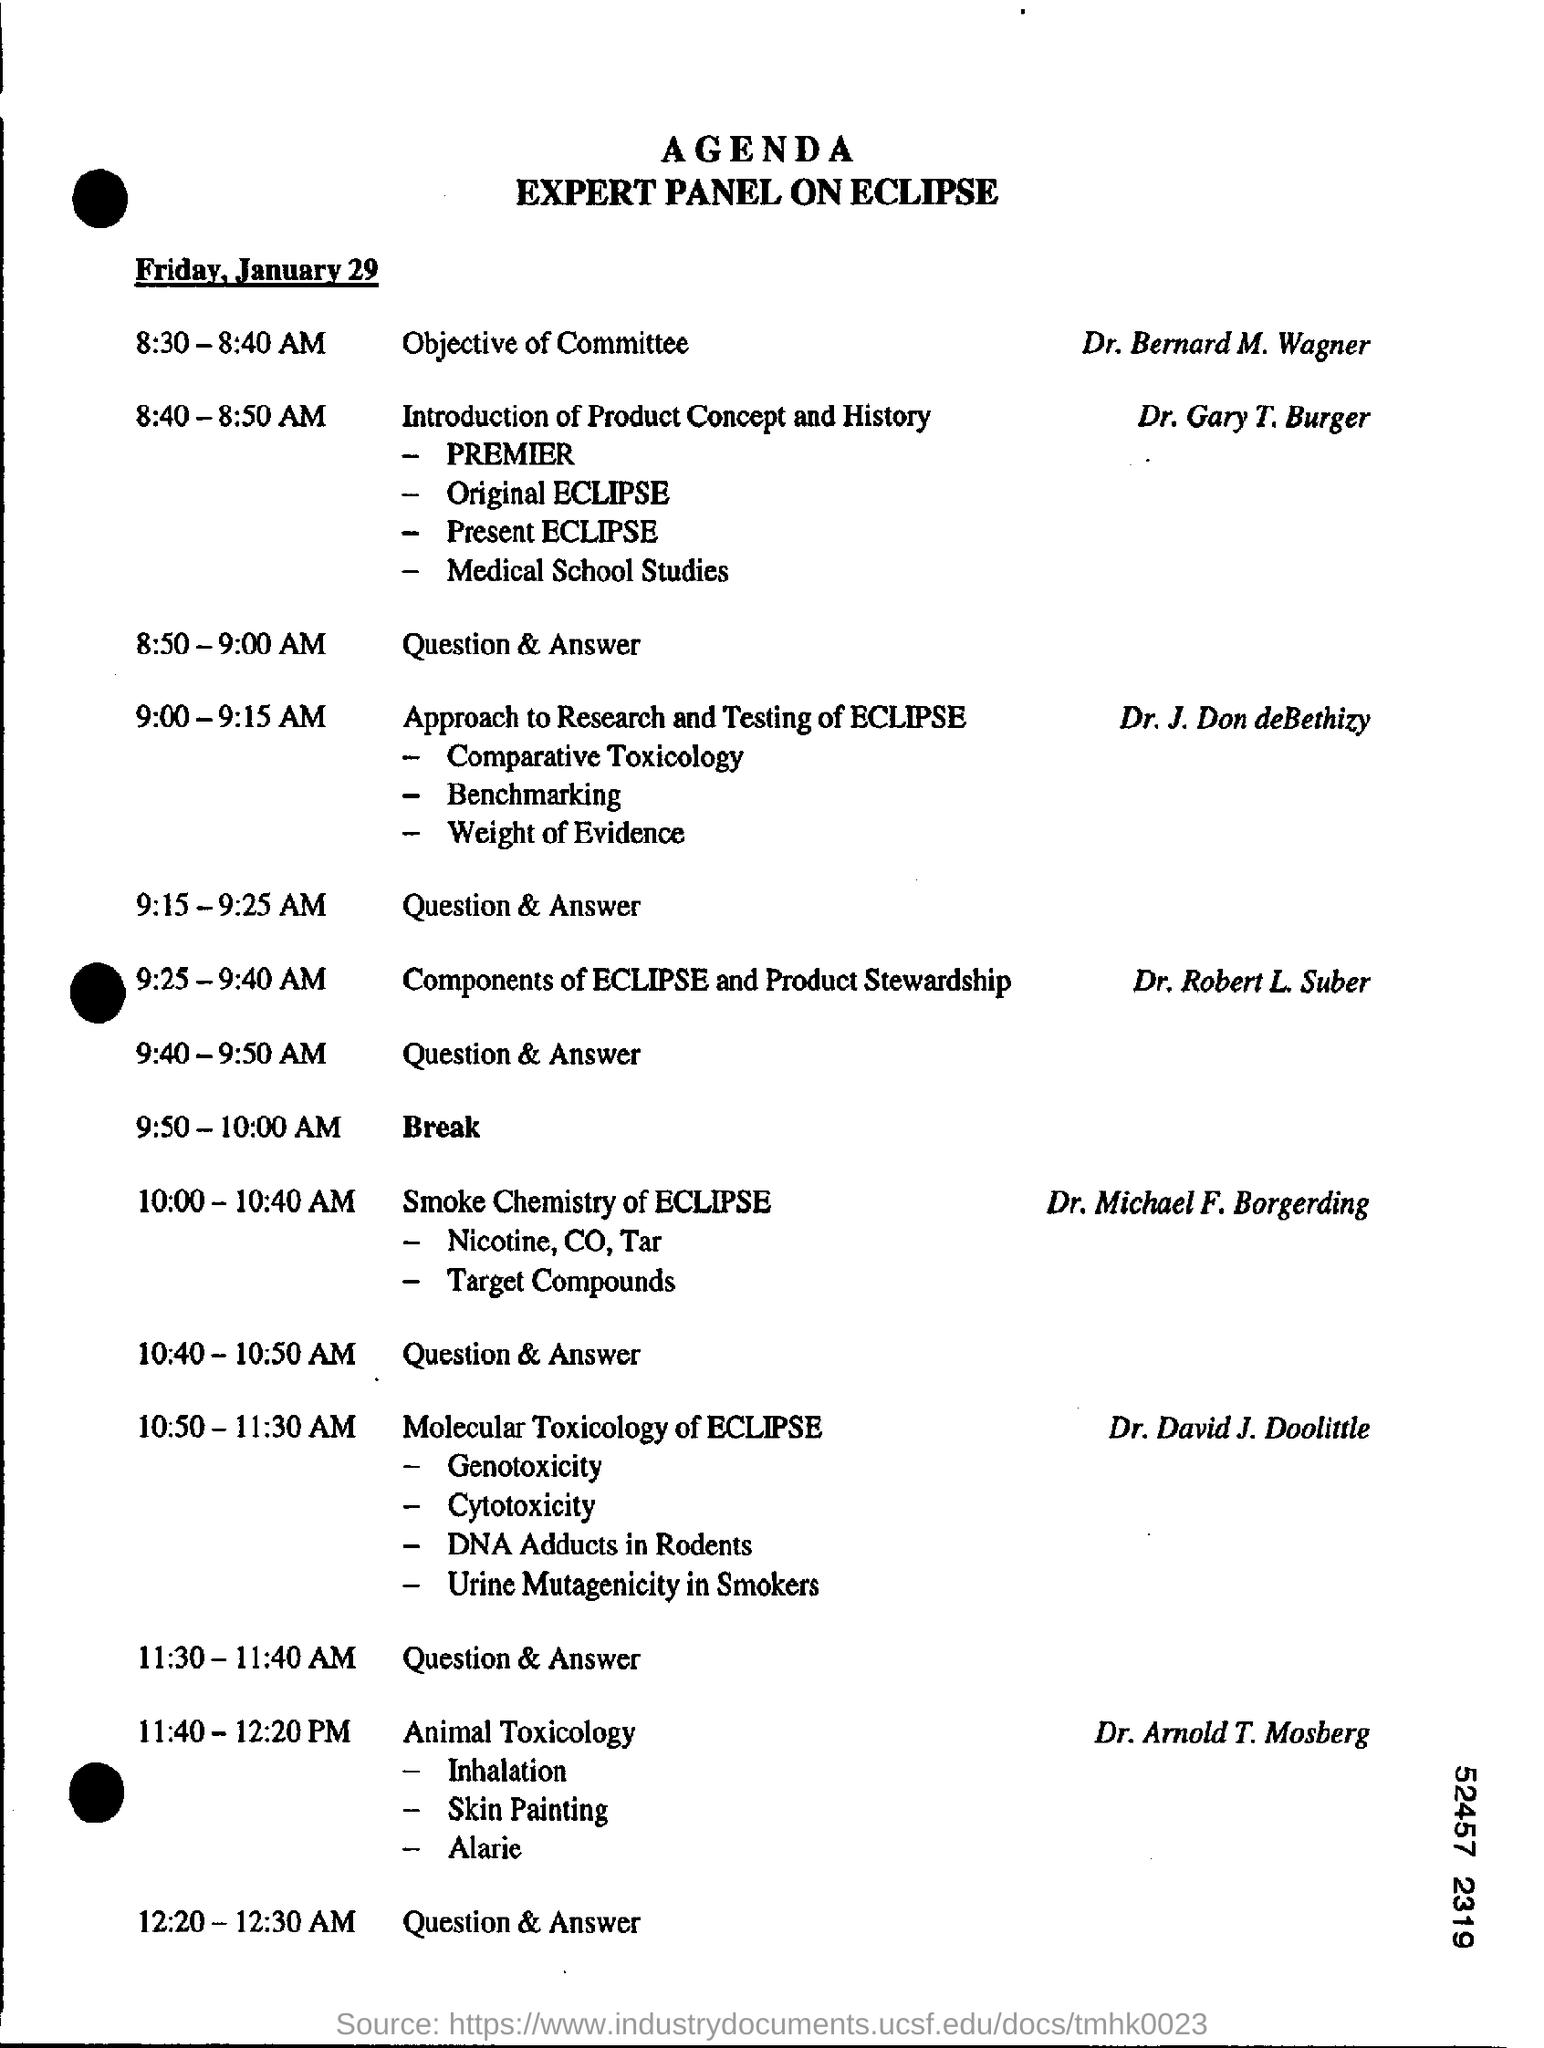List a handful of essential elements in this visual. Dr. Arnold T. Mosberg is speaking on the topic of animal toxicology. The break is scheduled to take place from 9:50-10:00 AM. Dr. Gary T. Burger introduced and provided a history of the product concept. On January 29, Friday will occur. 